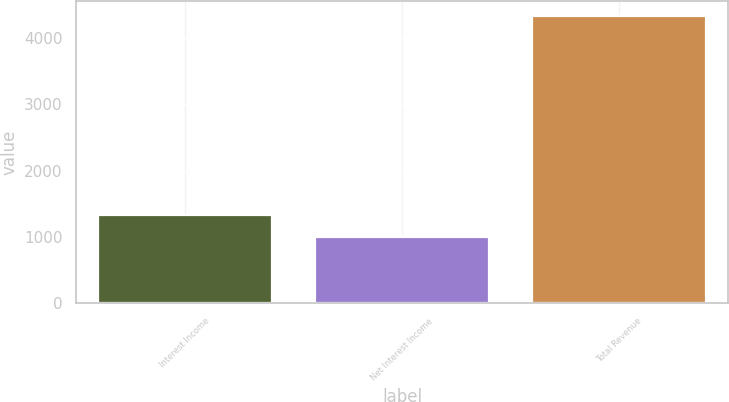<chart> <loc_0><loc_0><loc_500><loc_500><bar_chart><fcel>Interest Income<fcel>Net Interest Income<fcel>Total Revenue<nl><fcel>1338.07<fcel>1005.5<fcel>4331.2<nl></chart> 